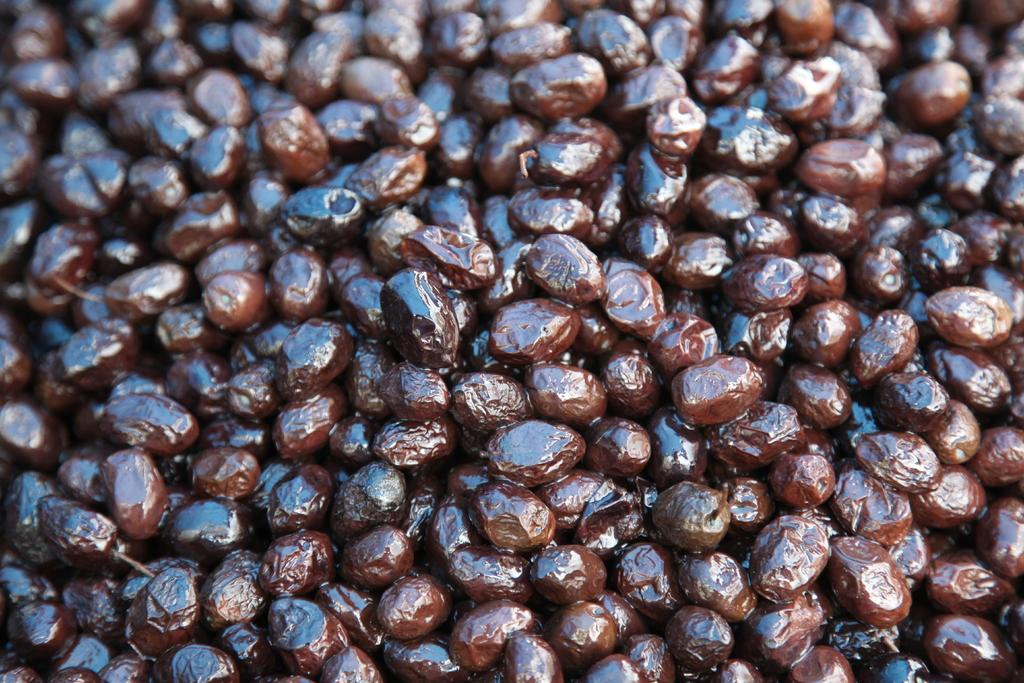What type of food can be seen in the image? There are fruits in the image. What color are the fruits? The fruits are brown in color. Is there any part of the image that is not clear? Yes, the part of the image containing the fruits is blurred. What type of base is supporting the fruits in the image? There is no base visible in the image; the fruits are not resting on any surface. 